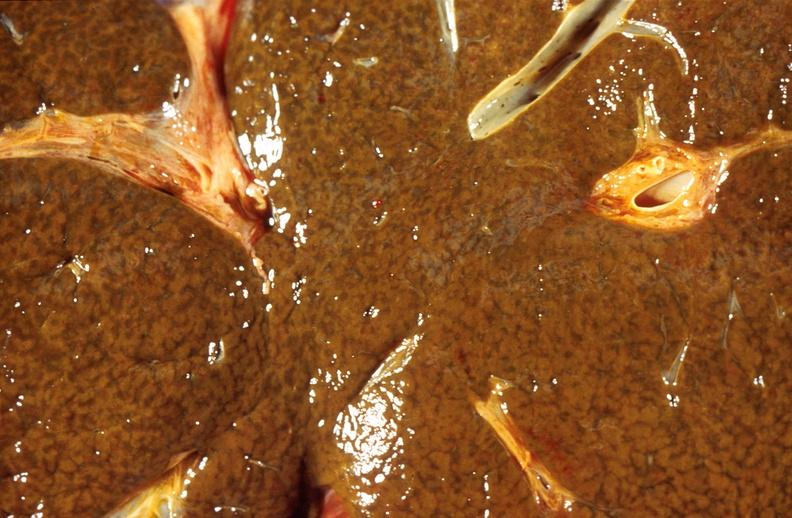s hepatobiliary present?
Answer the question using a single word or phrase. Yes 